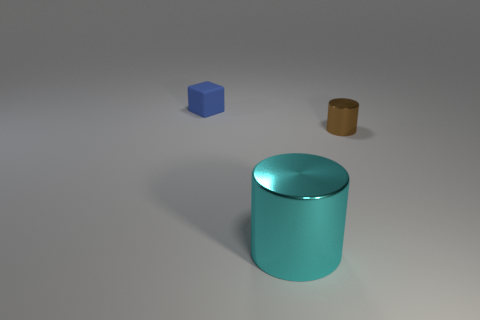What colors are shown in this image? The image displays a variety of colors. There is a blue cube, a teal cylindrical object, and a brown object that looks like a small cylinder or a disk. The background is a neutral grey tone. 